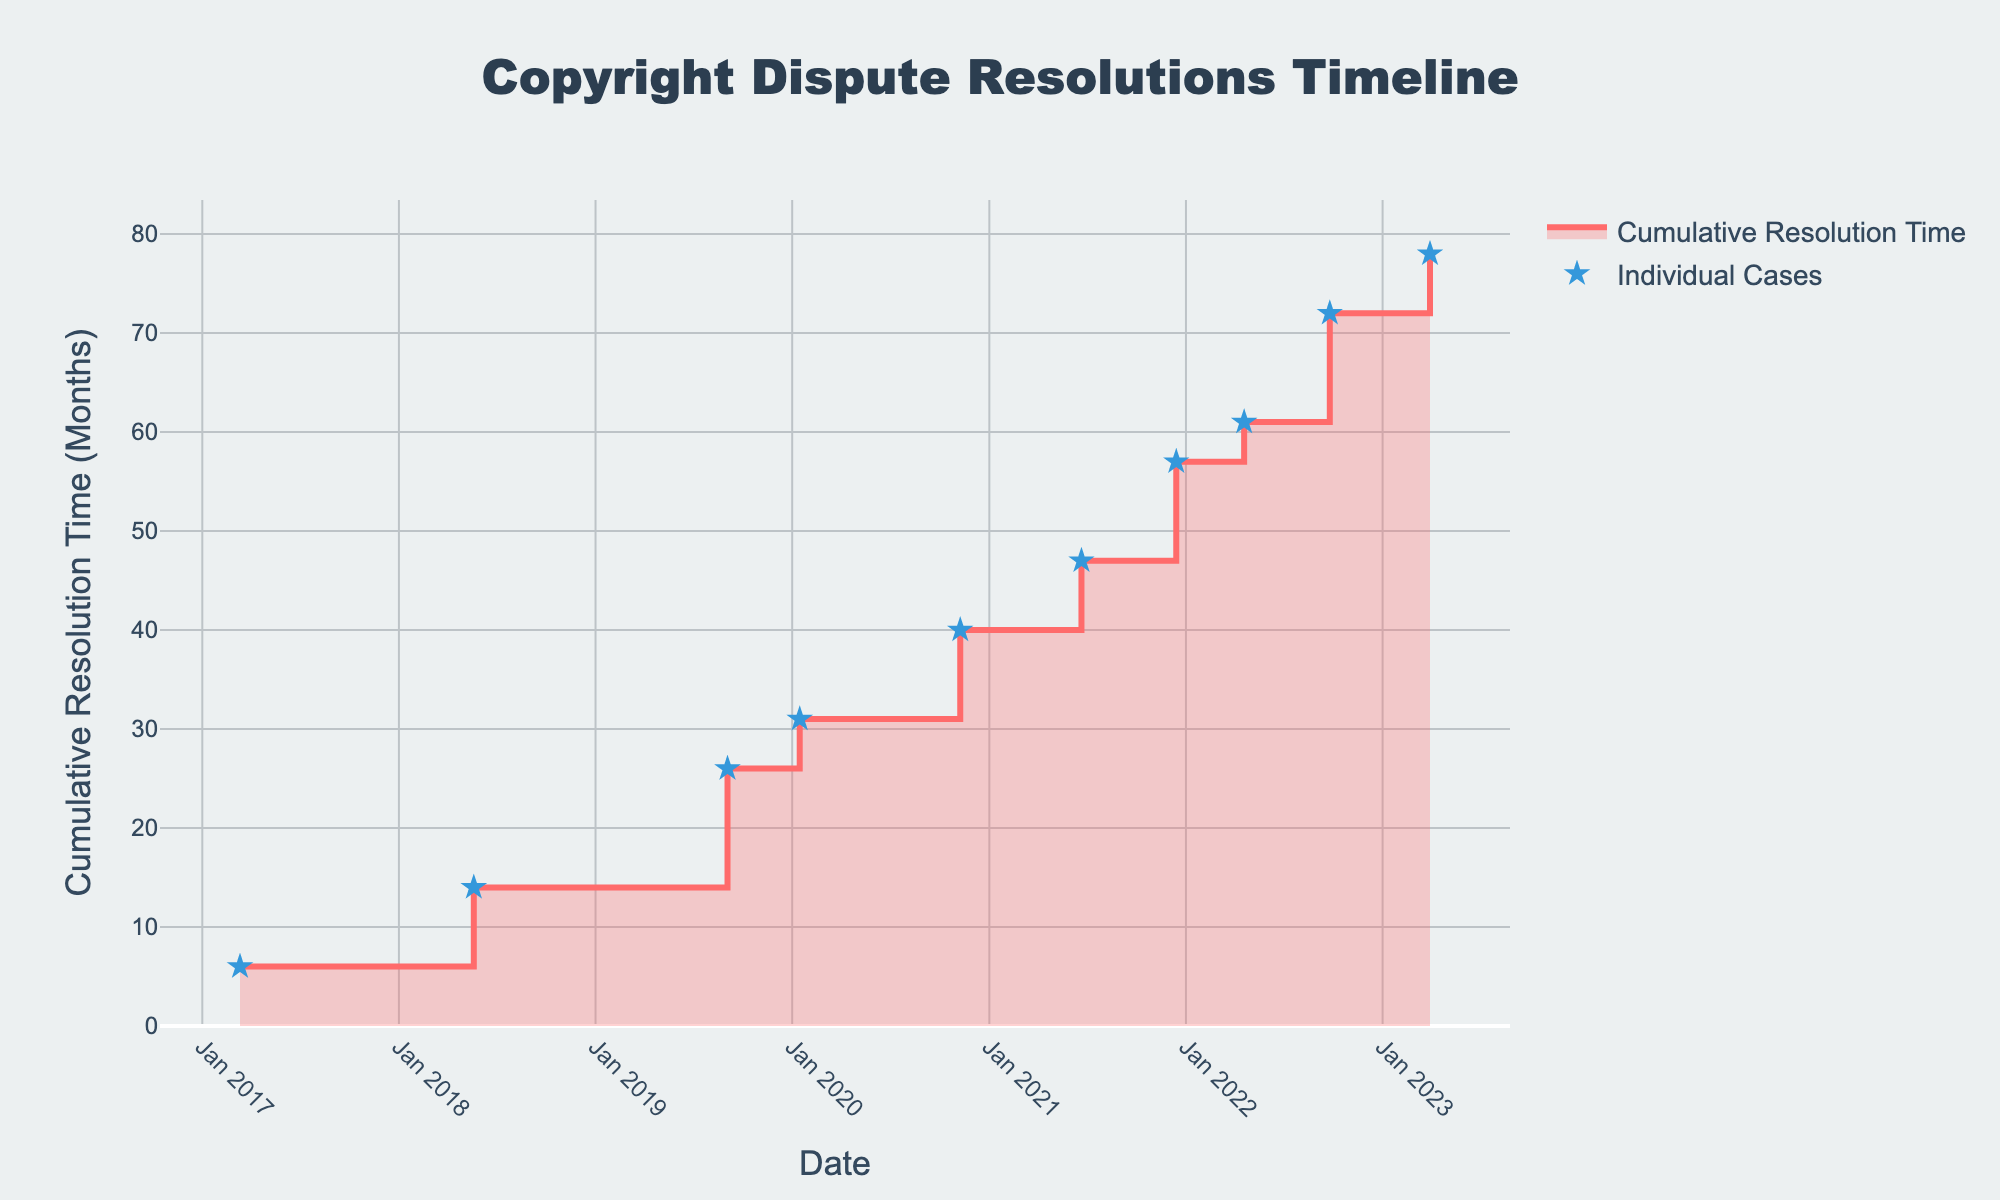What's the title of the chart? The chart's title is usually positioned at the top of the figure, providing a summary of the displayed data. Here, it is labeled "Copyright Dispute Resolutions Timeline."
Answer: Copyright Dispute Resolutions Timeline How many data points are plotted in the figure? Count the number of markers or distinct data points indicated on the chart. By looking at each marked point, you can count a total of 10 data points.
Answer: 10 What is the cumulative resolution time by the end of 2020? Locate the point corresponding to the last date of 2020 (end of December). Check the cumulative resolution time value at that point, which shows the sum of resolution times up till then.
Answer: 40 months Which month and year does the cumulative resolution time reach 50 months? Identify the data point where the cumulative resolution time first hits 50 months. Trace back to the corresponding date on the x-axis, which is evident at "June 2021."
Answer: June 2021 What is the difference in cumulative resolution time between the cases in May 2018 and September 2022? First, identify the cumulative resolution times at May 2018 and September 2022 from their respective data points. Subtract the cumulative resolution time in May 2018 (14 months) from that in September 2022 (78 months).
Answer: 64 months Between which two cases is the greatest increase in cumulative resolution time observed? Compare the increments in cumulative resolution time between all successive data points. The largest increment occurs between December 2021 (72 months) and September 2022 (83 months) representing a 11-month increase.
Answer: December 2021 and September 2022 What was the cumulative resolution time in Mar 2020? Find the cumulative resolution time at March 2020 by locating the corresponding date and observing the cumulative resolution time up to that point. It came to 23 months.
Answer: 23 months Which case showed a resolution time of 6 months after March 2023? Locate the data point at March 2023 and identify the corresponding case ID and resolution time, which together represents the case handled by Animal Planet.
Answer: Case010 How many total months of resolution time were added in 2022? Review the data points in 2022 and sum the individual resolution times: 4 months in April 2022 and 11 months in September 2022, leading to a cumulative 15 months.
Answer: 15 months What shape does the line follow in the chart, and why might this be appropriate for this data type? Observe the chart line, realizing it forms step-like segments. This shape, indicative of the step area chart, ensures each resolution is shown sequentially, emphasizing non-continuous increments pertinent to individual cases.
Answer: Step-like segments 